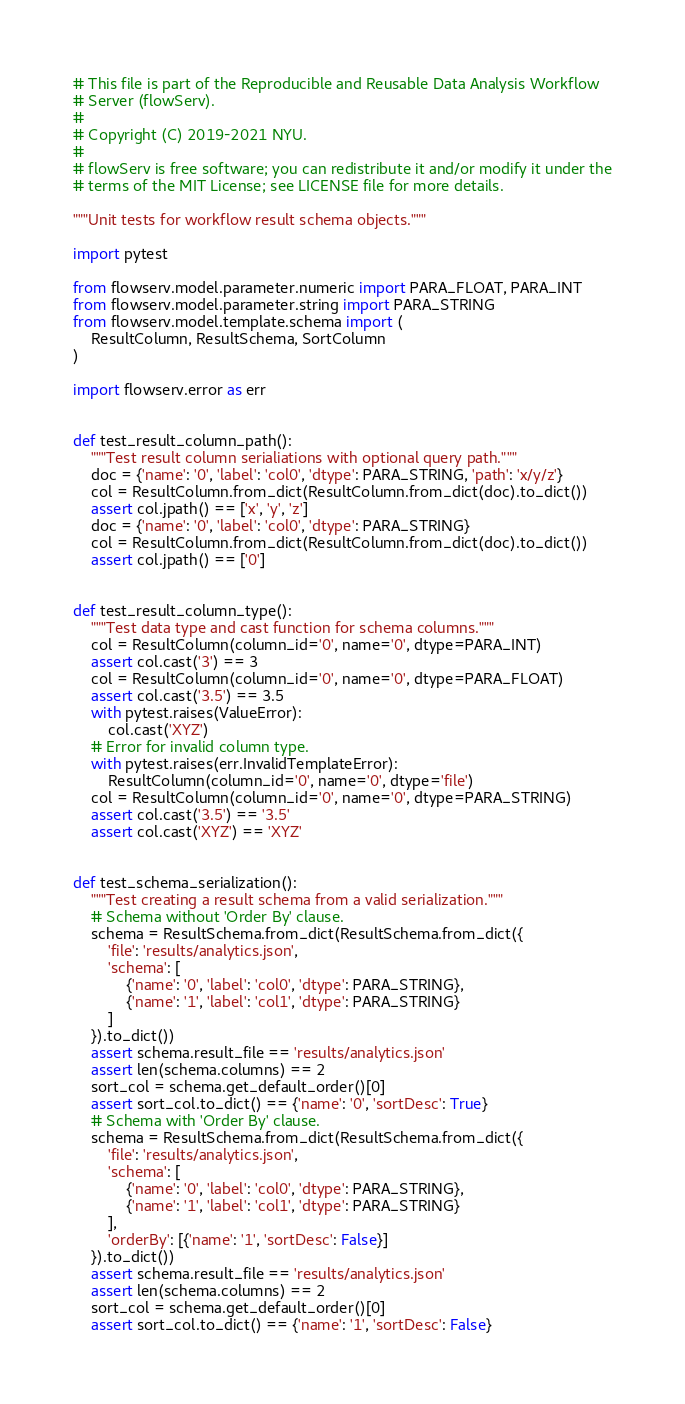<code> <loc_0><loc_0><loc_500><loc_500><_Python_># This file is part of the Reproducible and Reusable Data Analysis Workflow
# Server (flowServ).
#
# Copyright (C) 2019-2021 NYU.
#
# flowServ is free software; you can redistribute it and/or modify it under the
# terms of the MIT License; see LICENSE file for more details.

"""Unit tests for workflow result schema objects."""

import pytest

from flowserv.model.parameter.numeric import PARA_FLOAT, PARA_INT
from flowserv.model.parameter.string import PARA_STRING
from flowserv.model.template.schema import (
    ResultColumn, ResultSchema, SortColumn
)

import flowserv.error as err


def test_result_column_path():
    """Test result column serialiations with optional query path."""
    doc = {'name': '0', 'label': 'col0', 'dtype': PARA_STRING, 'path': 'x/y/z'}
    col = ResultColumn.from_dict(ResultColumn.from_dict(doc).to_dict())
    assert col.jpath() == ['x', 'y', 'z']
    doc = {'name': '0', 'label': 'col0', 'dtype': PARA_STRING}
    col = ResultColumn.from_dict(ResultColumn.from_dict(doc).to_dict())
    assert col.jpath() == ['0']


def test_result_column_type():
    """Test data type and cast function for schema columns."""
    col = ResultColumn(column_id='0', name='0', dtype=PARA_INT)
    assert col.cast('3') == 3
    col = ResultColumn(column_id='0', name='0', dtype=PARA_FLOAT)
    assert col.cast('3.5') == 3.5
    with pytest.raises(ValueError):
        col.cast('XYZ')
    # Error for invalid column type.
    with pytest.raises(err.InvalidTemplateError):
        ResultColumn(column_id='0', name='0', dtype='file')
    col = ResultColumn(column_id='0', name='0', dtype=PARA_STRING)
    assert col.cast('3.5') == '3.5'
    assert col.cast('XYZ') == 'XYZ'


def test_schema_serialization():
    """Test creating a result schema from a valid serialization."""
    # Schema without 'Order By' clause.
    schema = ResultSchema.from_dict(ResultSchema.from_dict({
        'file': 'results/analytics.json',
        'schema': [
            {'name': '0', 'label': 'col0', 'dtype': PARA_STRING},
            {'name': '1', 'label': 'col1', 'dtype': PARA_STRING}
        ]
    }).to_dict())
    assert schema.result_file == 'results/analytics.json'
    assert len(schema.columns) == 2
    sort_col = schema.get_default_order()[0]
    assert sort_col.to_dict() == {'name': '0', 'sortDesc': True}
    # Schema with 'Order By' clause.
    schema = ResultSchema.from_dict(ResultSchema.from_dict({
        'file': 'results/analytics.json',
        'schema': [
            {'name': '0', 'label': 'col0', 'dtype': PARA_STRING},
            {'name': '1', 'label': 'col1', 'dtype': PARA_STRING}
        ],
        'orderBy': [{'name': '1', 'sortDesc': False}]
    }).to_dict())
    assert schema.result_file == 'results/analytics.json'
    assert len(schema.columns) == 2
    sort_col = schema.get_default_order()[0]
    assert sort_col.to_dict() == {'name': '1', 'sortDesc': False}</code> 